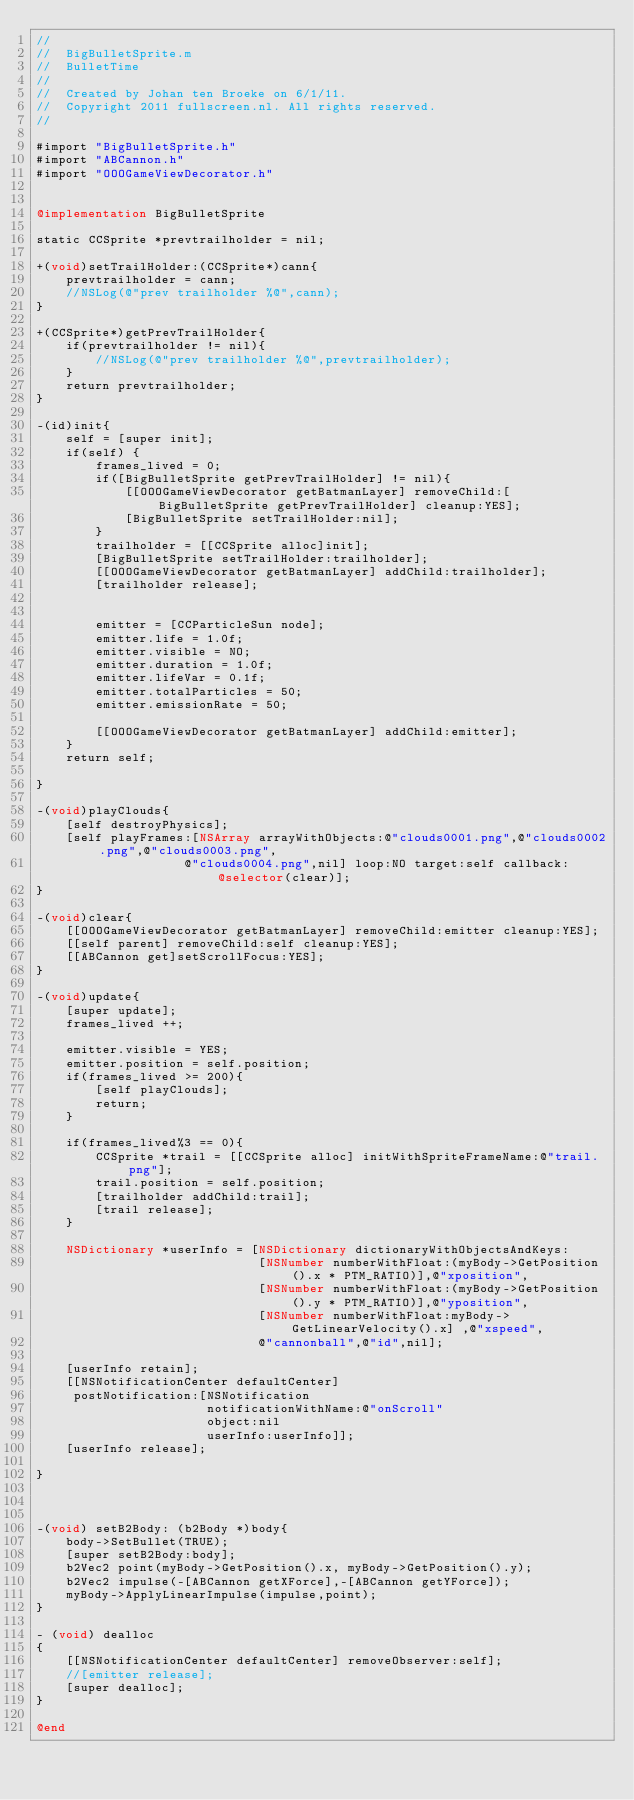Convert code to text. <code><loc_0><loc_0><loc_500><loc_500><_ObjectiveC_>//
//  BigBulletSprite.m
//  BulletTime
//
//  Created by Johan ten Broeke on 6/1/11.
//  Copyright 2011 fullscreen.nl. All rights reserved.
//

#import "BigBulletSprite.h"
#import "ABCannon.h"
#import "OOOGameViewDecorator.h"


@implementation BigBulletSprite

static CCSprite *prevtrailholder = nil;

+(void)setTrailHolder:(CCSprite*)cann{
    prevtrailholder = cann;
    //NSLog(@"prev trailholder %@",cann);
}

+(CCSprite*)getPrevTrailHolder{
    if(prevtrailholder != nil){
        //NSLog(@"prev trailholder %@",prevtrailholder);
    }
    return prevtrailholder;
}

-(id)init{
    self = [super init];
	if(self) {
		frames_lived = 0;
        if([BigBulletSprite getPrevTrailHolder] != nil){
            [[OOOGameViewDecorator getBatmanLayer] removeChild:[BigBulletSprite getPrevTrailHolder] cleanup:YES];
            [BigBulletSprite setTrailHolder:nil];
        }
        trailholder = [[CCSprite alloc]init];
        [BigBulletSprite setTrailHolder:trailholder];
        [[OOOGameViewDecorator getBatmanLayer] addChild:trailholder];
        [trailholder release];
	
	
        emitter = [CCParticleSun node];
        emitter.life = 1.0f;
        emitter.visible = NO;
        emitter.duration = 1.0f;
        emitter.lifeVar = 0.1f;
        emitter.totalParticles = 50;
        emitter.emissionRate = 50;
        
        [[OOOGameViewDecorator getBatmanLayer] addChild:emitter];
    }
	return self;
	
}

-(void)playClouds{
    [self destroyPhysics];
    [self playFrames:[NSArray arrayWithObjects:@"clouds0001.png",@"clouds0002.png",@"clouds0003.png",
                    @"clouds0004.png",nil] loop:NO target:self callback:@selector(clear)];
}

-(void)clear{
    [[OOOGameViewDecorator getBatmanLayer] removeChild:emitter cleanup:YES];
    [[self parent] removeChild:self cleanup:YES];
    [[ABCannon get]setScrollFocus:YES];
}

-(void)update{
	[super update];
	frames_lived ++;
	
	emitter.visible = YES;
	emitter.position = self.position;
	if(frames_lived >= 200){
        [self playClouds];
        return;
	}
    
    if(frames_lived%3 == 0){
        CCSprite *trail = [[CCSprite alloc] initWithSpriteFrameName:@"trail.png"];
        trail.position = self.position;
        [trailholder addChild:trail];
        [trail release];
    }
    
    NSDictionary *userInfo = [NSDictionary dictionaryWithObjectsAndKeys:
                              [NSNumber numberWithFloat:(myBody->GetPosition().x * PTM_RATIO)],@"xposition",
                              [NSNumber numberWithFloat:(myBody->GetPosition().y * PTM_RATIO)],@"yposition",
                              [NSNumber numberWithFloat:myBody->GetLinearVelocity().x] ,@"xspeed",
                              @"cannonball",@"id",nil];
    
    [userInfo retain];
    [[NSNotificationCenter defaultCenter] 
     postNotification:[NSNotification 
                       notificationWithName:@"onScroll" 
                       object:nil
                       userInfo:userInfo]];
    [userInfo release];
    
}



-(void) setB2Body: (b2Body *)body{
	body->SetBullet(TRUE);
	[super setB2Body:body];
	b2Vec2 point(myBody->GetPosition().x, myBody->GetPosition().y);
	b2Vec2 impulse(-[ABCannon getXForce],-[ABCannon getYForce]);
	myBody->ApplyLinearImpulse(impulse,point);
}

- (void) dealloc
{
	[[NSNotificationCenter defaultCenter] removeObserver:self]; 
	//[emitter release];
	[super dealloc];
}

@end
</code> 